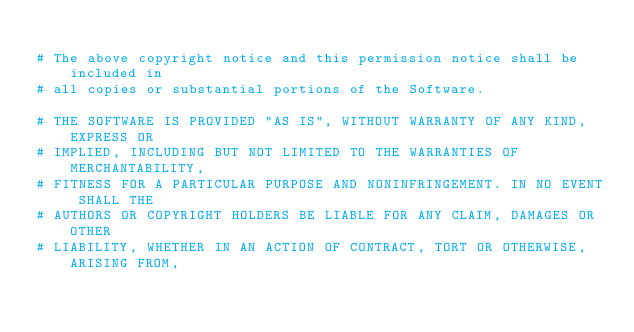<code> <loc_0><loc_0><loc_500><loc_500><_Ruby_>
# The above copyright notice and this permission notice shall be included in
# all copies or substantial portions of the Software.

# THE SOFTWARE IS PROVIDED "AS IS", WITHOUT WARRANTY OF ANY KIND, EXPRESS OR
# IMPLIED, INCLUDING BUT NOT LIMITED TO THE WARRANTIES OF MERCHANTABILITY,
# FITNESS FOR A PARTICULAR PURPOSE AND NONINFRINGEMENT. IN NO EVENT SHALL THE
# AUTHORS OR COPYRIGHT HOLDERS BE LIABLE FOR ANY CLAIM, DAMAGES OR OTHER
# LIABILITY, WHETHER IN AN ACTION OF CONTRACT, TORT OR OTHERWISE, ARISING FROM,</code> 